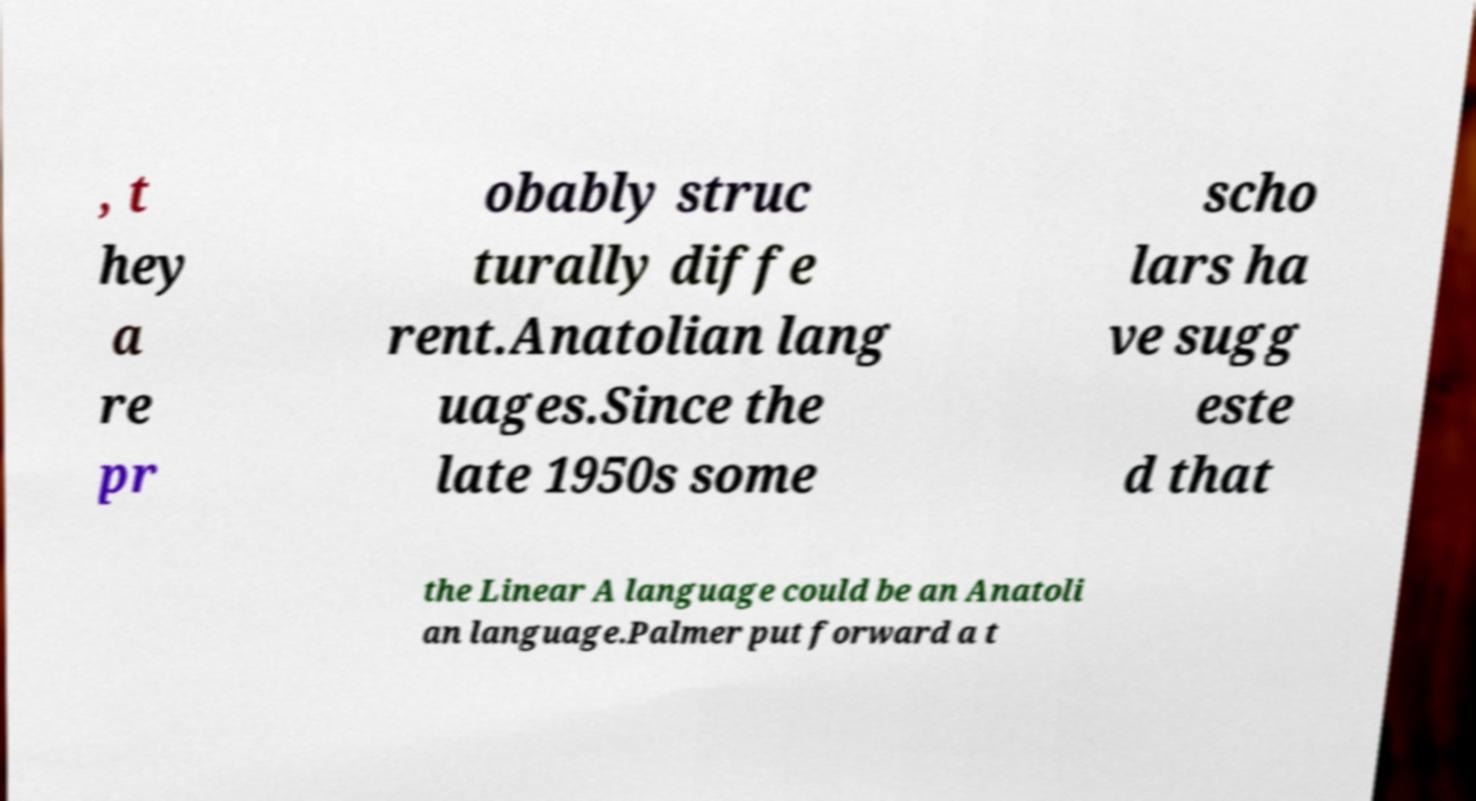Please read and relay the text visible in this image. What does it say? , t hey a re pr obably struc turally diffe rent.Anatolian lang uages.Since the late 1950s some scho lars ha ve sugg este d that the Linear A language could be an Anatoli an language.Palmer put forward a t 